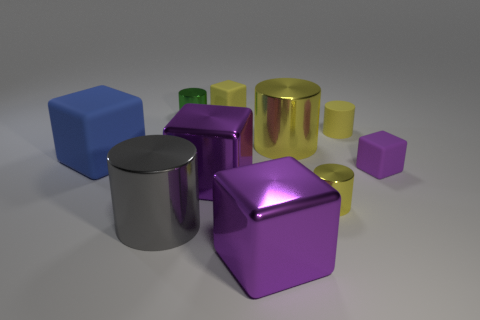Subtract all purple blocks. How many were subtracted if there are1purple blocks left? 2 Subtract all brown blocks. How many yellow cylinders are left? 3 Subtract all green cylinders. How many cylinders are left? 4 Subtract 1 cubes. How many cubes are left? 4 Subtract all large gray metal cylinders. How many cylinders are left? 4 Subtract all red cubes. Subtract all brown cylinders. How many cubes are left? 5 Add 2 large rubber blocks. How many large rubber blocks are left? 3 Add 8 yellow cubes. How many yellow cubes exist? 9 Subtract 0 green blocks. How many objects are left? 10 Subtract all big objects. Subtract all tiny purple cubes. How many objects are left? 4 